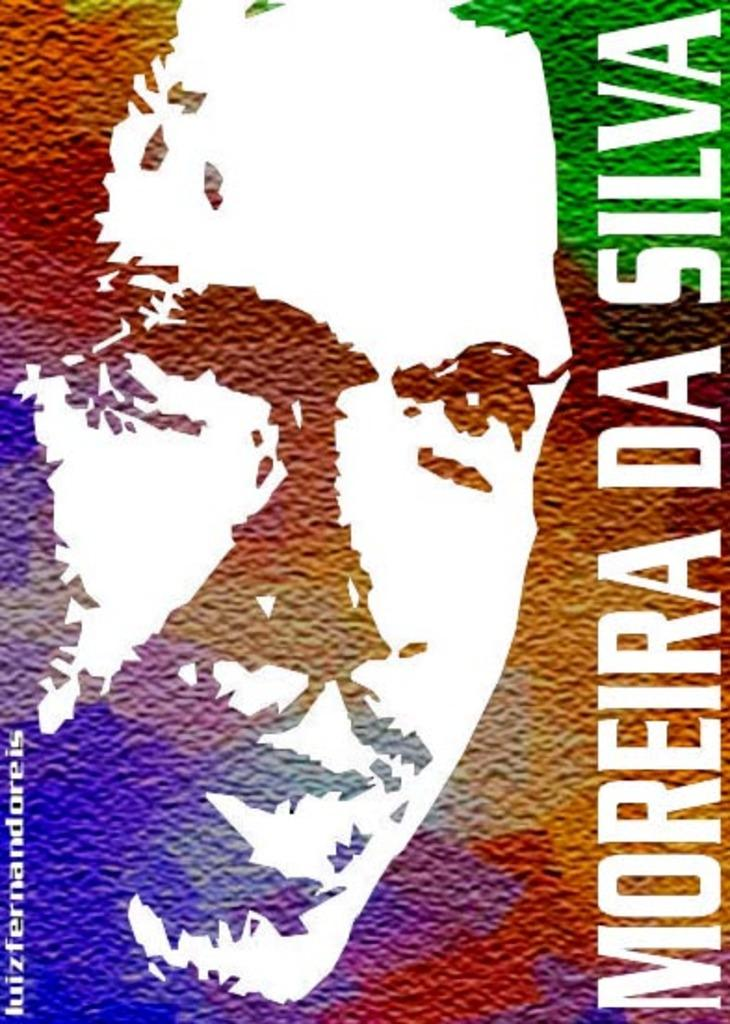<image>
Share a concise interpretation of the image provided. The artistic picture and name of a man is being displayed 